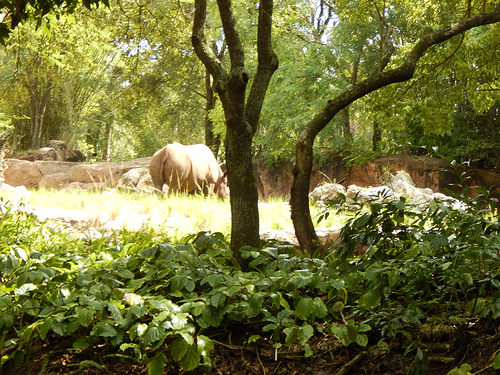<image>
Is the rhino in front of the tree? No. The rhino is not in front of the tree. The spatial positioning shows a different relationship between these objects. 